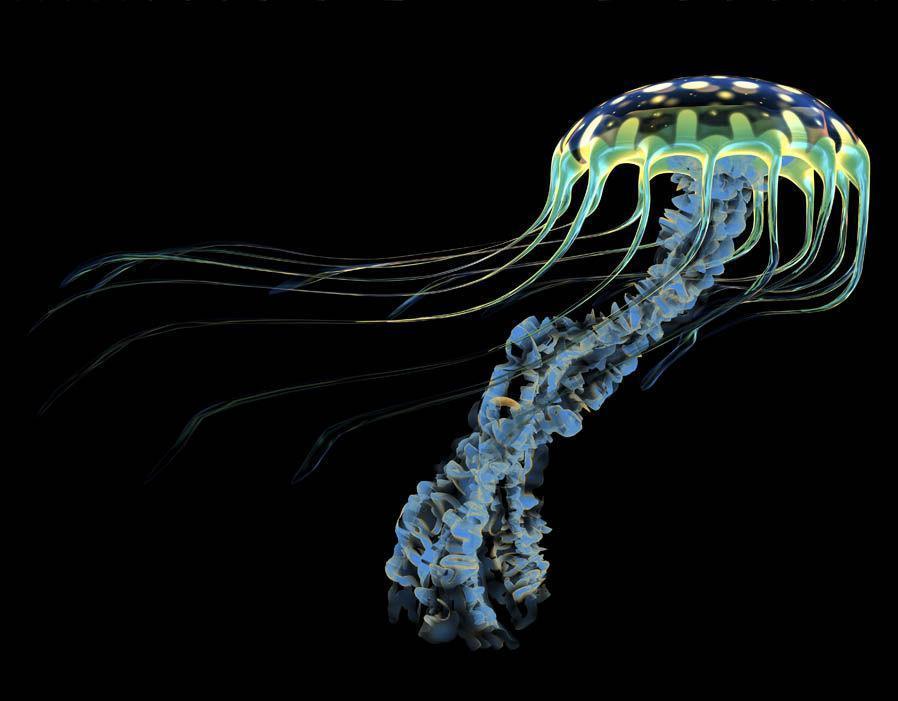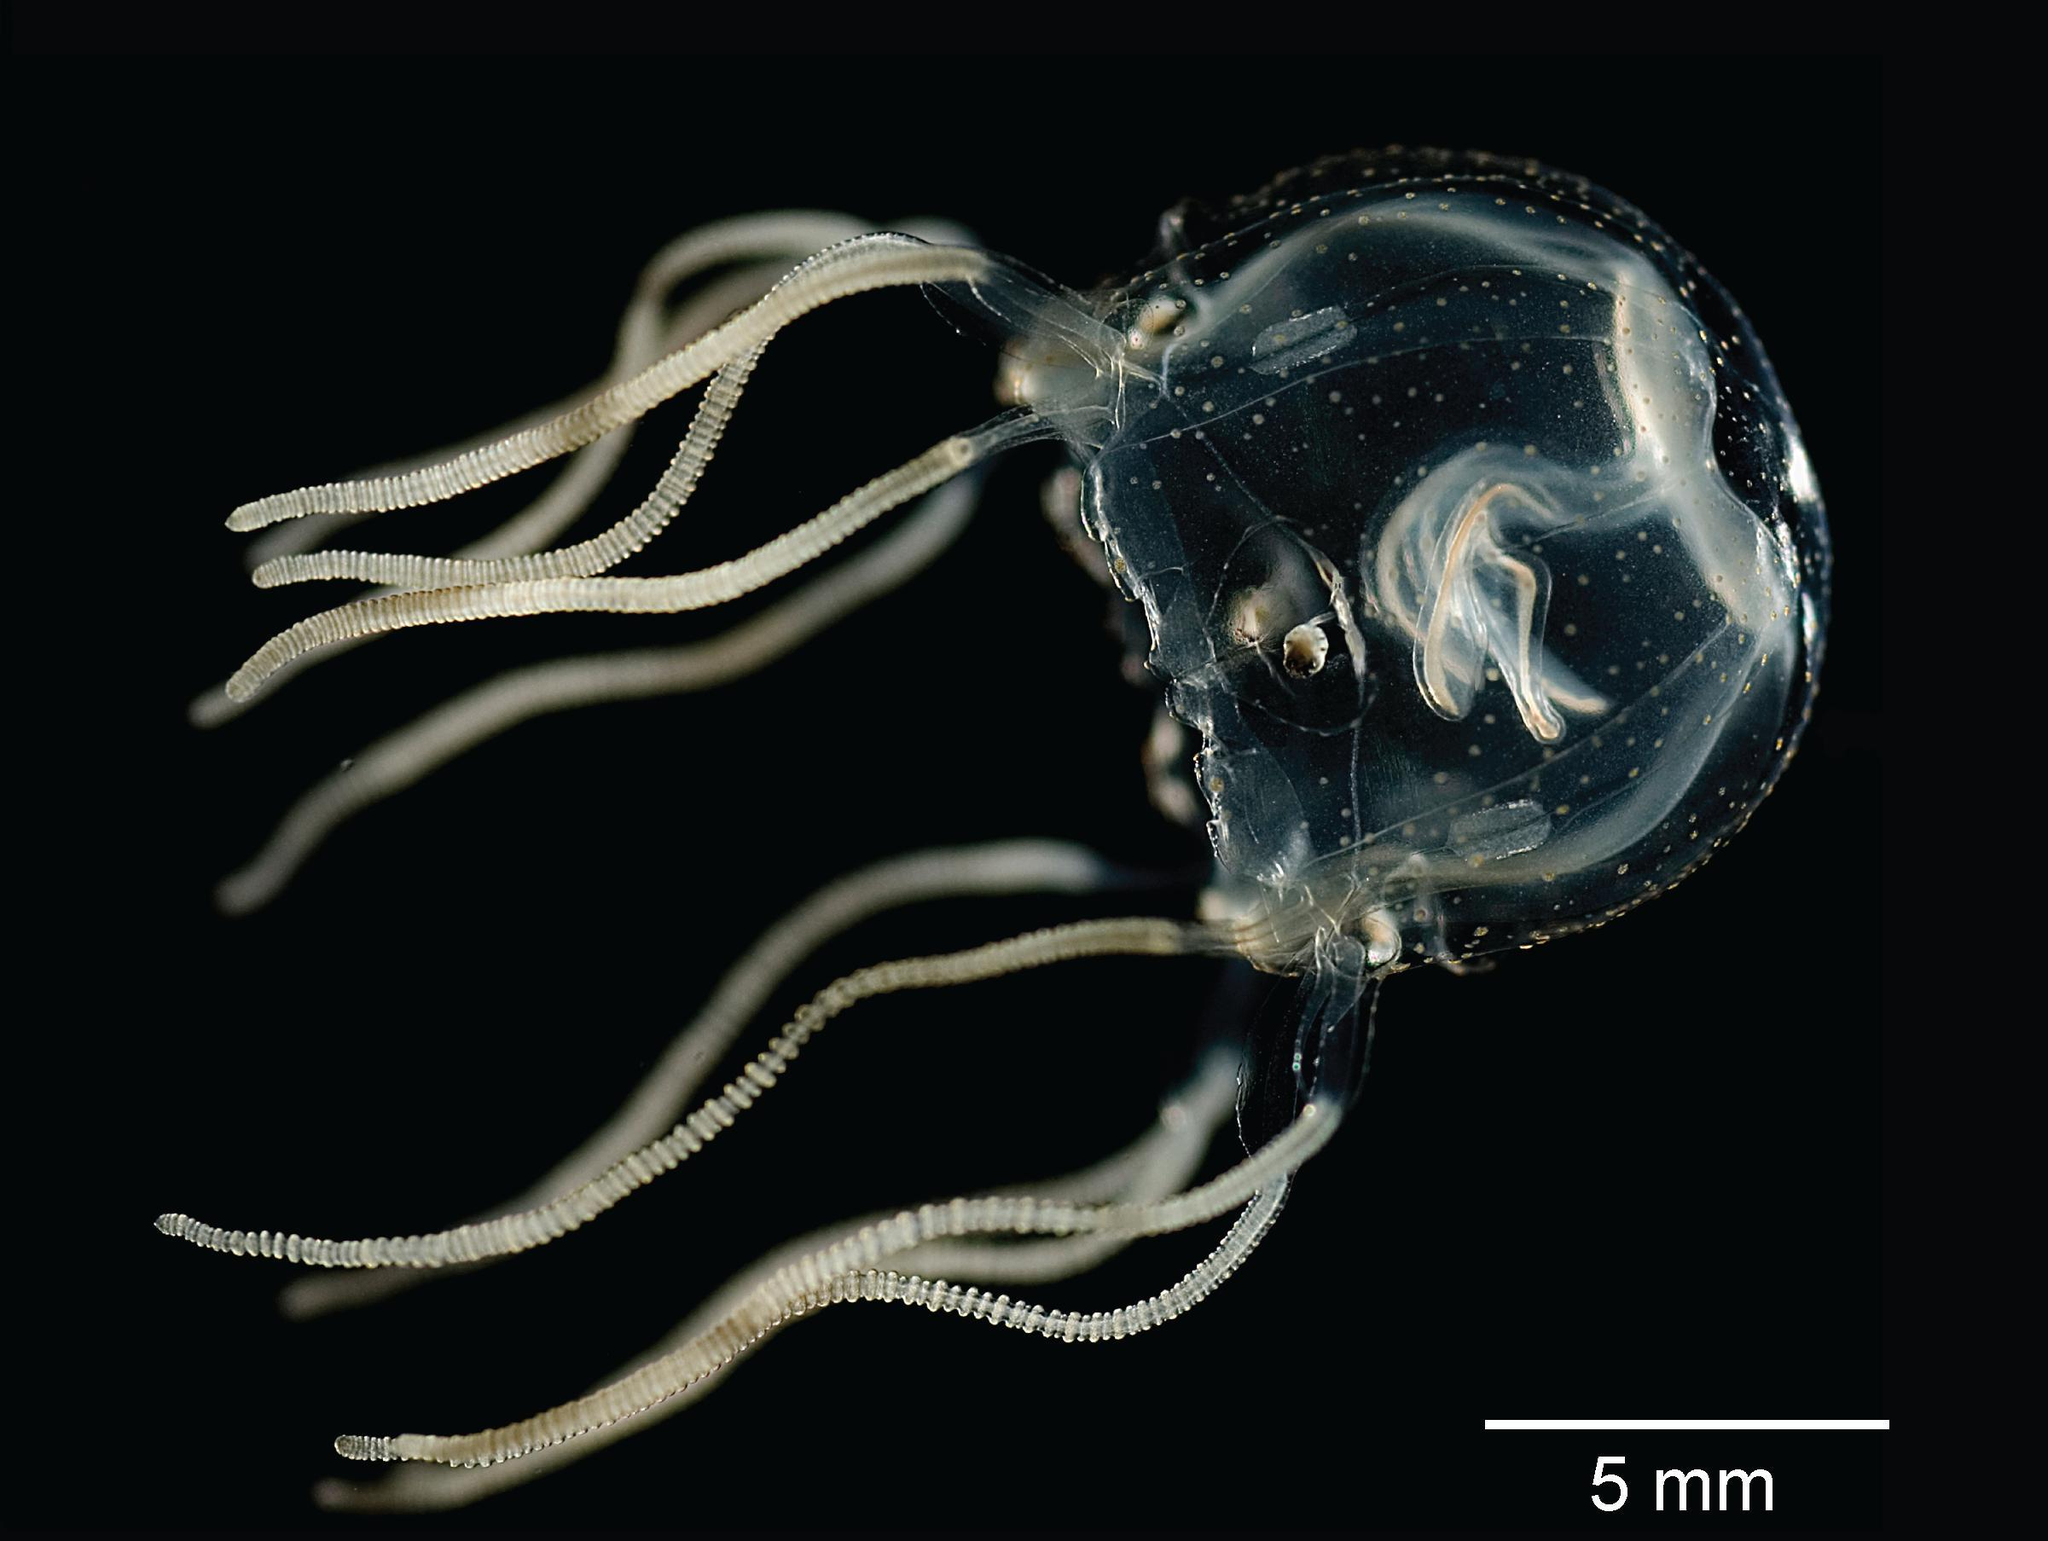The first image is the image on the left, the second image is the image on the right. For the images shown, is this caption "Two jellyfish, one in each image, have similar body shape and color and long thread-like tendrills, but the tendrills are flowing back in differing directions." true? Answer yes or no. No. The first image is the image on the left, the second image is the image on the right. Evaluate the accuracy of this statement regarding the images: "Each image shows a jellyfish with only long string-like tentacles trailing from a gumdrop-shaped body.". Is it true? Answer yes or no. No. 